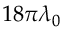<formula> <loc_0><loc_0><loc_500><loc_500>1 8 \pi \lambda _ { 0 }</formula> 